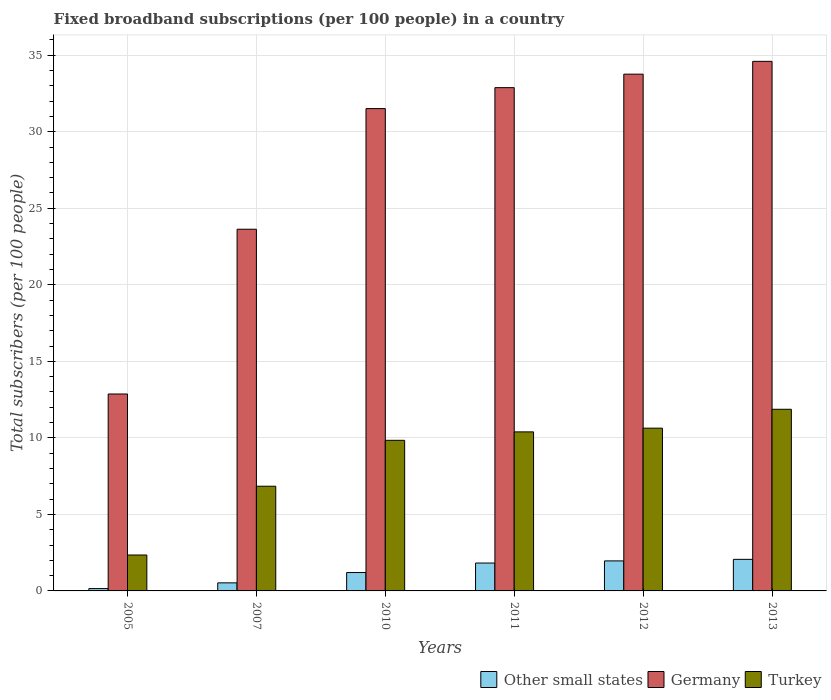Are the number of bars on each tick of the X-axis equal?
Offer a very short reply. Yes. How many bars are there on the 6th tick from the left?
Provide a short and direct response. 3. How many bars are there on the 3rd tick from the right?
Make the answer very short. 3. In how many cases, is the number of bars for a given year not equal to the number of legend labels?
Make the answer very short. 0. What is the number of broadband subscriptions in Germany in 2012?
Give a very brief answer. 33.76. Across all years, what is the maximum number of broadband subscriptions in Other small states?
Ensure brevity in your answer.  2.06. Across all years, what is the minimum number of broadband subscriptions in Germany?
Offer a very short reply. 12.87. In which year was the number of broadband subscriptions in Turkey minimum?
Offer a terse response. 2005. What is the total number of broadband subscriptions in Germany in the graph?
Your answer should be very brief. 169.26. What is the difference between the number of broadband subscriptions in Germany in 2010 and that in 2013?
Give a very brief answer. -3.09. What is the difference between the number of broadband subscriptions in Turkey in 2007 and the number of broadband subscriptions in Germany in 2011?
Make the answer very short. -26.04. What is the average number of broadband subscriptions in Turkey per year?
Provide a succinct answer. 8.65. In the year 2013, what is the difference between the number of broadband subscriptions in Germany and number of broadband subscriptions in Other small states?
Your response must be concise. 32.54. What is the ratio of the number of broadband subscriptions in Germany in 2011 to that in 2013?
Offer a terse response. 0.95. Is the difference between the number of broadband subscriptions in Germany in 2005 and 2013 greater than the difference between the number of broadband subscriptions in Other small states in 2005 and 2013?
Offer a very short reply. No. What is the difference between the highest and the second highest number of broadband subscriptions in Other small states?
Keep it short and to the point. 0.1. What is the difference between the highest and the lowest number of broadband subscriptions in Turkey?
Provide a succinct answer. 9.52. In how many years, is the number of broadband subscriptions in Other small states greater than the average number of broadband subscriptions in Other small states taken over all years?
Keep it short and to the point. 3. What does the 1st bar from the left in 2011 represents?
Offer a very short reply. Other small states. What does the 2nd bar from the right in 2012 represents?
Your answer should be very brief. Germany. Is it the case that in every year, the sum of the number of broadband subscriptions in Other small states and number of broadband subscriptions in Turkey is greater than the number of broadband subscriptions in Germany?
Give a very brief answer. No. What is the difference between two consecutive major ticks on the Y-axis?
Your answer should be compact. 5. Are the values on the major ticks of Y-axis written in scientific E-notation?
Make the answer very short. No. Does the graph contain any zero values?
Make the answer very short. No. Where does the legend appear in the graph?
Offer a terse response. Bottom right. How many legend labels are there?
Your answer should be compact. 3. What is the title of the graph?
Your answer should be very brief. Fixed broadband subscriptions (per 100 people) in a country. Does "Lebanon" appear as one of the legend labels in the graph?
Keep it short and to the point. No. What is the label or title of the Y-axis?
Your answer should be very brief. Total subscribers (per 100 people). What is the Total subscribers (per 100 people) in Other small states in 2005?
Give a very brief answer. 0.15. What is the Total subscribers (per 100 people) in Germany in 2005?
Your answer should be compact. 12.87. What is the Total subscribers (per 100 people) of Turkey in 2005?
Your response must be concise. 2.35. What is the Total subscribers (per 100 people) of Other small states in 2007?
Make the answer very short. 0.53. What is the Total subscribers (per 100 people) in Germany in 2007?
Your response must be concise. 23.63. What is the Total subscribers (per 100 people) of Turkey in 2007?
Keep it short and to the point. 6.84. What is the Total subscribers (per 100 people) in Other small states in 2010?
Your answer should be very brief. 1.2. What is the Total subscribers (per 100 people) of Germany in 2010?
Ensure brevity in your answer.  31.51. What is the Total subscribers (per 100 people) of Turkey in 2010?
Your answer should be very brief. 9.84. What is the Total subscribers (per 100 people) of Other small states in 2011?
Ensure brevity in your answer.  1.82. What is the Total subscribers (per 100 people) in Germany in 2011?
Make the answer very short. 32.88. What is the Total subscribers (per 100 people) of Turkey in 2011?
Offer a very short reply. 10.39. What is the Total subscribers (per 100 people) in Other small states in 2012?
Ensure brevity in your answer.  1.96. What is the Total subscribers (per 100 people) in Germany in 2012?
Provide a succinct answer. 33.76. What is the Total subscribers (per 100 people) of Turkey in 2012?
Keep it short and to the point. 10.63. What is the Total subscribers (per 100 people) of Other small states in 2013?
Make the answer very short. 2.06. What is the Total subscribers (per 100 people) of Germany in 2013?
Give a very brief answer. 34.6. What is the Total subscribers (per 100 people) in Turkey in 2013?
Your response must be concise. 11.87. Across all years, what is the maximum Total subscribers (per 100 people) of Other small states?
Give a very brief answer. 2.06. Across all years, what is the maximum Total subscribers (per 100 people) of Germany?
Offer a terse response. 34.6. Across all years, what is the maximum Total subscribers (per 100 people) in Turkey?
Your response must be concise. 11.87. Across all years, what is the minimum Total subscribers (per 100 people) in Other small states?
Offer a terse response. 0.15. Across all years, what is the minimum Total subscribers (per 100 people) in Germany?
Make the answer very short. 12.87. Across all years, what is the minimum Total subscribers (per 100 people) in Turkey?
Offer a very short reply. 2.35. What is the total Total subscribers (per 100 people) of Other small states in the graph?
Offer a very short reply. 7.73. What is the total Total subscribers (per 100 people) in Germany in the graph?
Make the answer very short. 169.26. What is the total Total subscribers (per 100 people) of Turkey in the graph?
Provide a short and direct response. 51.92. What is the difference between the Total subscribers (per 100 people) of Other small states in 2005 and that in 2007?
Your answer should be very brief. -0.37. What is the difference between the Total subscribers (per 100 people) in Germany in 2005 and that in 2007?
Your answer should be compact. -10.77. What is the difference between the Total subscribers (per 100 people) of Turkey in 2005 and that in 2007?
Make the answer very short. -4.49. What is the difference between the Total subscribers (per 100 people) of Other small states in 2005 and that in 2010?
Offer a terse response. -1.05. What is the difference between the Total subscribers (per 100 people) in Germany in 2005 and that in 2010?
Your answer should be compact. -18.65. What is the difference between the Total subscribers (per 100 people) in Turkey in 2005 and that in 2010?
Keep it short and to the point. -7.49. What is the difference between the Total subscribers (per 100 people) of Other small states in 2005 and that in 2011?
Make the answer very short. -1.67. What is the difference between the Total subscribers (per 100 people) in Germany in 2005 and that in 2011?
Make the answer very short. -20.02. What is the difference between the Total subscribers (per 100 people) of Turkey in 2005 and that in 2011?
Offer a very short reply. -8.04. What is the difference between the Total subscribers (per 100 people) of Other small states in 2005 and that in 2012?
Your answer should be very brief. -1.81. What is the difference between the Total subscribers (per 100 people) of Germany in 2005 and that in 2012?
Offer a terse response. -20.9. What is the difference between the Total subscribers (per 100 people) in Turkey in 2005 and that in 2012?
Ensure brevity in your answer.  -8.29. What is the difference between the Total subscribers (per 100 people) in Other small states in 2005 and that in 2013?
Ensure brevity in your answer.  -1.91. What is the difference between the Total subscribers (per 100 people) in Germany in 2005 and that in 2013?
Give a very brief answer. -21.73. What is the difference between the Total subscribers (per 100 people) of Turkey in 2005 and that in 2013?
Provide a short and direct response. -9.52. What is the difference between the Total subscribers (per 100 people) of Other small states in 2007 and that in 2010?
Ensure brevity in your answer.  -0.67. What is the difference between the Total subscribers (per 100 people) in Germany in 2007 and that in 2010?
Your answer should be very brief. -7.88. What is the difference between the Total subscribers (per 100 people) of Turkey in 2007 and that in 2010?
Ensure brevity in your answer.  -3. What is the difference between the Total subscribers (per 100 people) in Other small states in 2007 and that in 2011?
Your answer should be compact. -1.29. What is the difference between the Total subscribers (per 100 people) of Germany in 2007 and that in 2011?
Provide a short and direct response. -9.25. What is the difference between the Total subscribers (per 100 people) in Turkey in 2007 and that in 2011?
Provide a succinct answer. -3.55. What is the difference between the Total subscribers (per 100 people) in Other small states in 2007 and that in 2012?
Provide a short and direct response. -1.44. What is the difference between the Total subscribers (per 100 people) in Germany in 2007 and that in 2012?
Your answer should be very brief. -10.13. What is the difference between the Total subscribers (per 100 people) in Turkey in 2007 and that in 2012?
Keep it short and to the point. -3.79. What is the difference between the Total subscribers (per 100 people) of Other small states in 2007 and that in 2013?
Your answer should be very brief. -1.54. What is the difference between the Total subscribers (per 100 people) of Germany in 2007 and that in 2013?
Your answer should be compact. -10.97. What is the difference between the Total subscribers (per 100 people) in Turkey in 2007 and that in 2013?
Your answer should be very brief. -5.03. What is the difference between the Total subscribers (per 100 people) in Other small states in 2010 and that in 2011?
Provide a succinct answer. -0.62. What is the difference between the Total subscribers (per 100 people) in Germany in 2010 and that in 2011?
Your answer should be compact. -1.37. What is the difference between the Total subscribers (per 100 people) in Turkey in 2010 and that in 2011?
Offer a terse response. -0.55. What is the difference between the Total subscribers (per 100 people) in Other small states in 2010 and that in 2012?
Keep it short and to the point. -0.76. What is the difference between the Total subscribers (per 100 people) in Germany in 2010 and that in 2012?
Give a very brief answer. -2.25. What is the difference between the Total subscribers (per 100 people) in Turkey in 2010 and that in 2012?
Provide a short and direct response. -0.79. What is the difference between the Total subscribers (per 100 people) in Other small states in 2010 and that in 2013?
Your response must be concise. -0.86. What is the difference between the Total subscribers (per 100 people) of Germany in 2010 and that in 2013?
Provide a succinct answer. -3.09. What is the difference between the Total subscribers (per 100 people) in Turkey in 2010 and that in 2013?
Ensure brevity in your answer.  -2.03. What is the difference between the Total subscribers (per 100 people) of Other small states in 2011 and that in 2012?
Your answer should be compact. -0.14. What is the difference between the Total subscribers (per 100 people) of Germany in 2011 and that in 2012?
Give a very brief answer. -0.88. What is the difference between the Total subscribers (per 100 people) of Turkey in 2011 and that in 2012?
Your answer should be very brief. -0.24. What is the difference between the Total subscribers (per 100 people) of Other small states in 2011 and that in 2013?
Ensure brevity in your answer.  -0.24. What is the difference between the Total subscribers (per 100 people) in Germany in 2011 and that in 2013?
Ensure brevity in your answer.  -1.72. What is the difference between the Total subscribers (per 100 people) of Turkey in 2011 and that in 2013?
Keep it short and to the point. -1.48. What is the difference between the Total subscribers (per 100 people) in Other small states in 2012 and that in 2013?
Give a very brief answer. -0.1. What is the difference between the Total subscribers (per 100 people) in Germany in 2012 and that in 2013?
Provide a short and direct response. -0.84. What is the difference between the Total subscribers (per 100 people) in Turkey in 2012 and that in 2013?
Provide a succinct answer. -1.23. What is the difference between the Total subscribers (per 100 people) in Other small states in 2005 and the Total subscribers (per 100 people) in Germany in 2007?
Provide a short and direct response. -23.48. What is the difference between the Total subscribers (per 100 people) in Other small states in 2005 and the Total subscribers (per 100 people) in Turkey in 2007?
Give a very brief answer. -6.69. What is the difference between the Total subscribers (per 100 people) of Germany in 2005 and the Total subscribers (per 100 people) of Turkey in 2007?
Offer a terse response. 6.03. What is the difference between the Total subscribers (per 100 people) in Other small states in 2005 and the Total subscribers (per 100 people) in Germany in 2010?
Provide a short and direct response. -31.36. What is the difference between the Total subscribers (per 100 people) of Other small states in 2005 and the Total subscribers (per 100 people) of Turkey in 2010?
Provide a short and direct response. -9.69. What is the difference between the Total subscribers (per 100 people) of Germany in 2005 and the Total subscribers (per 100 people) of Turkey in 2010?
Ensure brevity in your answer.  3.03. What is the difference between the Total subscribers (per 100 people) of Other small states in 2005 and the Total subscribers (per 100 people) of Germany in 2011?
Offer a very short reply. -32.73. What is the difference between the Total subscribers (per 100 people) of Other small states in 2005 and the Total subscribers (per 100 people) of Turkey in 2011?
Your answer should be compact. -10.24. What is the difference between the Total subscribers (per 100 people) of Germany in 2005 and the Total subscribers (per 100 people) of Turkey in 2011?
Your answer should be very brief. 2.48. What is the difference between the Total subscribers (per 100 people) in Other small states in 2005 and the Total subscribers (per 100 people) in Germany in 2012?
Your response must be concise. -33.61. What is the difference between the Total subscribers (per 100 people) in Other small states in 2005 and the Total subscribers (per 100 people) in Turkey in 2012?
Provide a short and direct response. -10.48. What is the difference between the Total subscribers (per 100 people) in Germany in 2005 and the Total subscribers (per 100 people) in Turkey in 2012?
Your response must be concise. 2.23. What is the difference between the Total subscribers (per 100 people) of Other small states in 2005 and the Total subscribers (per 100 people) of Germany in 2013?
Offer a terse response. -34.45. What is the difference between the Total subscribers (per 100 people) in Other small states in 2005 and the Total subscribers (per 100 people) in Turkey in 2013?
Offer a terse response. -11.72. What is the difference between the Total subscribers (per 100 people) of Other small states in 2007 and the Total subscribers (per 100 people) of Germany in 2010?
Ensure brevity in your answer.  -30.99. What is the difference between the Total subscribers (per 100 people) in Other small states in 2007 and the Total subscribers (per 100 people) in Turkey in 2010?
Your answer should be compact. -9.31. What is the difference between the Total subscribers (per 100 people) of Germany in 2007 and the Total subscribers (per 100 people) of Turkey in 2010?
Your answer should be compact. 13.79. What is the difference between the Total subscribers (per 100 people) of Other small states in 2007 and the Total subscribers (per 100 people) of Germany in 2011?
Your response must be concise. -32.36. What is the difference between the Total subscribers (per 100 people) of Other small states in 2007 and the Total subscribers (per 100 people) of Turkey in 2011?
Offer a terse response. -9.86. What is the difference between the Total subscribers (per 100 people) of Germany in 2007 and the Total subscribers (per 100 people) of Turkey in 2011?
Make the answer very short. 13.24. What is the difference between the Total subscribers (per 100 people) of Other small states in 2007 and the Total subscribers (per 100 people) of Germany in 2012?
Ensure brevity in your answer.  -33.24. What is the difference between the Total subscribers (per 100 people) of Other small states in 2007 and the Total subscribers (per 100 people) of Turkey in 2012?
Keep it short and to the point. -10.11. What is the difference between the Total subscribers (per 100 people) in Germany in 2007 and the Total subscribers (per 100 people) in Turkey in 2012?
Offer a very short reply. 13. What is the difference between the Total subscribers (per 100 people) in Other small states in 2007 and the Total subscribers (per 100 people) in Germany in 2013?
Offer a very short reply. -34.07. What is the difference between the Total subscribers (per 100 people) in Other small states in 2007 and the Total subscribers (per 100 people) in Turkey in 2013?
Make the answer very short. -11.34. What is the difference between the Total subscribers (per 100 people) in Germany in 2007 and the Total subscribers (per 100 people) in Turkey in 2013?
Offer a terse response. 11.76. What is the difference between the Total subscribers (per 100 people) of Other small states in 2010 and the Total subscribers (per 100 people) of Germany in 2011?
Provide a short and direct response. -31.68. What is the difference between the Total subscribers (per 100 people) of Other small states in 2010 and the Total subscribers (per 100 people) of Turkey in 2011?
Offer a very short reply. -9.19. What is the difference between the Total subscribers (per 100 people) in Germany in 2010 and the Total subscribers (per 100 people) in Turkey in 2011?
Make the answer very short. 21.12. What is the difference between the Total subscribers (per 100 people) in Other small states in 2010 and the Total subscribers (per 100 people) in Germany in 2012?
Make the answer very short. -32.56. What is the difference between the Total subscribers (per 100 people) in Other small states in 2010 and the Total subscribers (per 100 people) in Turkey in 2012?
Keep it short and to the point. -9.43. What is the difference between the Total subscribers (per 100 people) in Germany in 2010 and the Total subscribers (per 100 people) in Turkey in 2012?
Ensure brevity in your answer.  20.88. What is the difference between the Total subscribers (per 100 people) in Other small states in 2010 and the Total subscribers (per 100 people) in Germany in 2013?
Provide a short and direct response. -33.4. What is the difference between the Total subscribers (per 100 people) of Other small states in 2010 and the Total subscribers (per 100 people) of Turkey in 2013?
Your response must be concise. -10.67. What is the difference between the Total subscribers (per 100 people) of Germany in 2010 and the Total subscribers (per 100 people) of Turkey in 2013?
Keep it short and to the point. 19.65. What is the difference between the Total subscribers (per 100 people) of Other small states in 2011 and the Total subscribers (per 100 people) of Germany in 2012?
Your answer should be compact. -31.94. What is the difference between the Total subscribers (per 100 people) in Other small states in 2011 and the Total subscribers (per 100 people) in Turkey in 2012?
Keep it short and to the point. -8.81. What is the difference between the Total subscribers (per 100 people) in Germany in 2011 and the Total subscribers (per 100 people) in Turkey in 2012?
Provide a short and direct response. 22.25. What is the difference between the Total subscribers (per 100 people) in Other small states in 2011 and the Total subscribers (per 100 people) in Germany in 2013?
Your answer should be very brief. -32.78. What is the difference between the Total subscribers (per 100 people) in Other small states in 2011 and the Total subscribers (per 100 people) in Turkey in 2013?
Give a very brief answer. -10.05. What is the difference between the Total subscribers (per 100 people) in Germany in 2011 and the Total subscribers (per 100 people) in Turkey in 2013?
Ensure brevity in your answer.  21.01. What is the difference between the Total subscribers (per 100 people) in Other small states in 2012 and the Total subscribers (per 100 people) in Germany in 2013?
Provide a short and direct response. -32.64. What is the difference between the Total subscribers (per 100 people) of Other small states in 2012 and the Total subscribers (per 100 people) of Turkey in 2013?
Your answer should be compact. -9.91. What is the difference between the Total subscribers (per 100 people) of Germany in 2012 and the Total subscribers (per 100 people) of Turkey in 2013?
Provide a succinct answer. 21.9. What is the average Total subscribers (per 100 people) in Other small states per year?
Provide a short and direct response. 1.29. What is the average Total subscribers (per 100 people) in Germany per year?
Give a very brief answer. 28.21. What is the average Total subscribers (per 100 people) in Turkey per year?
Offer a very short reply. 8.65. In the year 2005, what is the difference between the Total subscribers (per 100 people) in Other small states and Total subscribers (per 100 people) in Germany?
Your response must be concise. -12.71. In the year 2005, what is the difference between the Total subscribers (per 100 people) of Other small states and Total subscribers (per 100 people) of Turkey?
Offer a terse response. -2.19. In the year 2005, what is the difference between the Total subscribers (per 100 people) in Germany and Total subscribers (per 100 people) in Turkey?
Make the answer very short. 10.52. In the year 2007, what is the difference between the Total subscribers (per 100 people) of Other small states and Total subscribers (per 100 people) of Germany?
Give a very brief answer. -23.11. In the year 2007, what is the difference between the Total subscribers (per 100 people) in Other small states and Total subscribers (per 100 people) in Turkey?
Make the answer very short. -6.31. In the year 2007, what is the difference between the Total subscribers (per 100 people) in Germany and Total subscribers (per 100 people) in Turkey?
Provide a short and direct response. 16.79. In the year 2010, what is the difference between the Total subscribers (per 100 people) in Other small states and Total subscribers (per 100 people) in Germany?
Your response must be concise. -30.31. In the year 2010, what is the difference between the Total subscribers (per 100 people) in Other small states and Total subscribers (per 100 people) in Turkey?
Provide a succinct answer. -8.64. In the year 2010, what is the difference between the Total subscribers (per 100 people) of Germany and Total subscribers (per 100 people) of Turkey?
Your response must be concise. 21.67. In the year 2011, what is the difference between the Total subscribers (per 100 people) of Other small states and Total subscribers (per 100 people) of Germany?
Offer a terse response. -31.06. In the year 2011, what is the difference between the Total subscribers (per 100 people) of Other small states and Total subscribers (per 100 people) of Turkey?
Offer a terse response. -8.57. In the year 2011, what is the difference between the Total subscribers (per 100 people) in Germany and Total subscribers (per 100 people) in Turkey?
Your answer should be very brief. 22.49. In the year 2012, what is the difference between the Total subscribers (per 100 people) in Other small states and Total subscribers (per 100 people) in Germany?
Give a very brief answer. -31.8. In the year 2012, what is the difference between the Total subscribers (per 100 people) in Other small states and Total subscribers (per 100 people) in Turkey?
Your response must be concise. -8.67. In the year 2012, what is the difference between the Total subscribers (per 100 people) in Germany and Total subscribers (per 100 people) in Turkey?
Offer a terse response. 23.13. In the year 2013, what is the difference between the Total subscribers (per 100 people) of Other small states and Total subscribers (per 100 people) of Germany?
Keep it short and to the point. -32.54. In the year 2013, what is the difference between the Total subscribers (per 100 people) in Other small states and Total subscribers (per 100 people) in Turkey?
Offer a terse response. -9.81. In the year 2013, what is the difference between the Total subscribers (per 100 people) of Germany and Total subscribers (per 100 people) of Turkey?
Provide a succinct answer. 22.73. What is the ratio of the Total subscribers (per 100 people) of Other small states in 2005 to that in 2007?
Provide a succinct answer. 0.29. What is the ratio of the Total subscribers (per 100 people) in Germany in 2005 to that in 2007?
Offer a very short reply. 0.54. What is the ratio of the Total subscribers (per 100 people) in Turkey in 2005 to that in 2007?
Keep it short and to the point. 0.34. What is the ratio of the Total subscribers (per 100 people) in Other small states in 2005 to that in 2010?
Ensure brevity in your answer.  0.13. What is the ratio of the Total subscribers (per 100 people) of Germany in 2005 to that in 2010?
Provide a short and direct response. 0.41. What is the ratio of the Total subscribers (per 100 people) of Turkey in 2005 to that in 2010?
Provide a short and direct response. 0.24. What is the ratio of the Total subscribers (per 100 people) in Other small states in 2005 to that in 2011?
Make the answer very short. 0.08. What is the ratio of the Total subscribers (per 100 people) of Germany in 2005 to that in 2011?
Make the answer very short. 0.39. What is the ratio of the Total subscribers (per 100 people) of Turkey in 2005 to that in 2011?
Give a very brief answer. 0.23. What is the ratio of the Total subscribers (per 100 people) in Other small states in 2005 to that in 2012?
Your answer should be very brief. 0.08. What is the ratio of the Total subscribers (per 100 people) of Germany in 2005 to that in 2012?
Make the answer very short. 0.38. What is the ratio of the Total subscribers (per 100 people) of Turkey in 2005 to that in 2012?
Your answer should be very brief. 0.22. What is the ratio of the Total subscribers (per 100 people) of Other small states in 2005 to that in 2013?
Your answer should be very brief. 0.07. What is the ratio of the Total subscribers (per 100 people) of Germany in 2005 to that in 2013?
Provide a succinct answer. 0.37. What is the ratio of the Total subscribers (per 100 people) in Turkey in 2005 to that in 2013?
Your response must be concise. 0.2. What is the ratio of the Total subscribers (per 100 people) of Other small states in 2007 to that in 2010?
Offer a terse response. 0.44. What is the ratio of the Total subscribers (per 100 people) in Germany in 2007 to that in 2010?
Ensure brevity in your answer.  0.75. What is the ratio of the Total subscribers (per 100 people) in Turkey in 2007 to that in 2010?
Your response must be concise. 0.7. What is the ratio of the Total subscribers (per 100 people) in Other small states in 2007 to that in 2011?
Make the answer very short. 0.29. What is the ratio of the Total subscribers (per 100 people) of Germany in 2007 to that in 2011?
Offer a terse response. 0.72. What is the ratio of the Total subscribers (per 100 people) in Turkey in 2007 to that in 2011?
Your answer should be very brief. 0.66. What is the ratio of the Total subscribers (per 100 people) of Other small states in 2007 to that in 2012?
Ensure brevity in your answer.  0.27. What is the ratio of the Total subscribers (per 100 people) of Germany in 2007 to that in 2012?
Offer a very short reply. 0.7. What is the ratio of the Total subscribers (per 100 people) in Turkey in 2007 to that in 2012?
Provide a short and direct response. 0.64. What is the ratio of the Total subscribers (per 100 people) in Other small states in 2007 to that in 2013?
Your answer should be very brief. 0.26. What is the ratio of the Total subscribers (per 100 people) of Germany in 2007 to that in 2013?
Provide a succinct answer. 0.68. What is the ratio of the Total subscribers (per 100 people) of Turkey in 2007 to that in 2013?
Your response must be concise. 0.58. What is the ratio of the Total subscribers (per 100 people) in Other small states in 2010 to that in 2011?
Your answer should be compact. 0.66. What is the ratio of the Total subscribers (per 100 people) in Germany in 2010 to that in 2011?
Keep it short and to the point. 0.96. What is the ratio of the Total subscribers (per 100 people) of Turkey in 2010 to that in 2011?
Offer a very short reply. 0.95. What is the ratio of the Total subscribers (per 100 people) in Other small states in 2010 to that in 2012?
Offer a terse response. 0.61. What is the ratio of the Total subscribers (per 100 people) of Germany in 2010 to that in 2012?
Keep it short and to the point. 0.93. What is the ratio of the Total subscribers (per 100 people) in Turkey in 2010 to that in 2012?
Ensure brevity in your answer.  0.93. What is the ratio of the Total subscribers (per 100 people) in Other small states in 2010 to that in 2013?
Provide a short and direct response. 0.58. What is the ratio of the Total subscribers (per 100 people) of Germany in 2010 to that in 2013?
Your answer should be very brief. 0.91. What is the ratio of the Total subscribers (per 100 people) in Turkey in 2010 to that in 2013?
Offer a very short reply. 0.83. What is the ratio of the Total subscribers (per 100 people) of Other small states in 2011 to that in 2012?
Your response must be concise. 0.93. What is the ratio of the Total subscribers (per 100 people) in Germany in 2011 to that in 2012?
Make the answer very short. 0.97. What is the ratio of the Total subscribers (per 100 people) in Turkey in 2011 to that in 2012?
Make the answer very short. 0.98. What is the ratio of the Total subscribers (per 100 people) of Other small states in 2011 to that in 2013?
Your answer should be very brief. 0.88. What is the ratio of the Total subscribers (per 100 people) of Germany in 2011 to that in 2013?
Keep it short and to the point. 0.95. What is the ratio of the Total subscribers (per 100 people) of Turkey in 2011 to that in 2013?
Your answer should be compact. 0.88. What is the ratio of the Total subscribers (per 100 people) of Other small states in 2012 to that in 2013?
Give a very brief answer. 0.95. What is the ratio of the Total subscribers (per 100 people) of Germany in 2012 to that in 2013?
Your answer should be very brief. 0.98. What is the ratio of the Total subscribers (per 100 people) in Turkey in 2012 to that in 2013?
Ensure brevity in your answer.  0.9. What is the difference between the highest and the second highest Total subscribers (per 100 people) in Other small states?
Your answer should be compact. 0.1. What is the difference between the highest and the second highest Total subscribers (per 100 people) of Germany?
Ensure brevity in your answer.  0.84. What is the difference between the highest and the second highest Total subscribers (per 100 people) in Turkey?
Ensure brevity in your answer.  1.23. What is the difference between the highest and the lowest Total subscribers (per 100 people) of Other small states?
Give a very brief answer. 1.91. What is the difference between the highest and the lowest Total subscribers (per 100 people) in Germany?
Provide a short and direct response. 21.73. What is the difference between the highest and the lowest Total subscribers (per 100 people) of Turkey?
Make the answer very short. 9.52. 